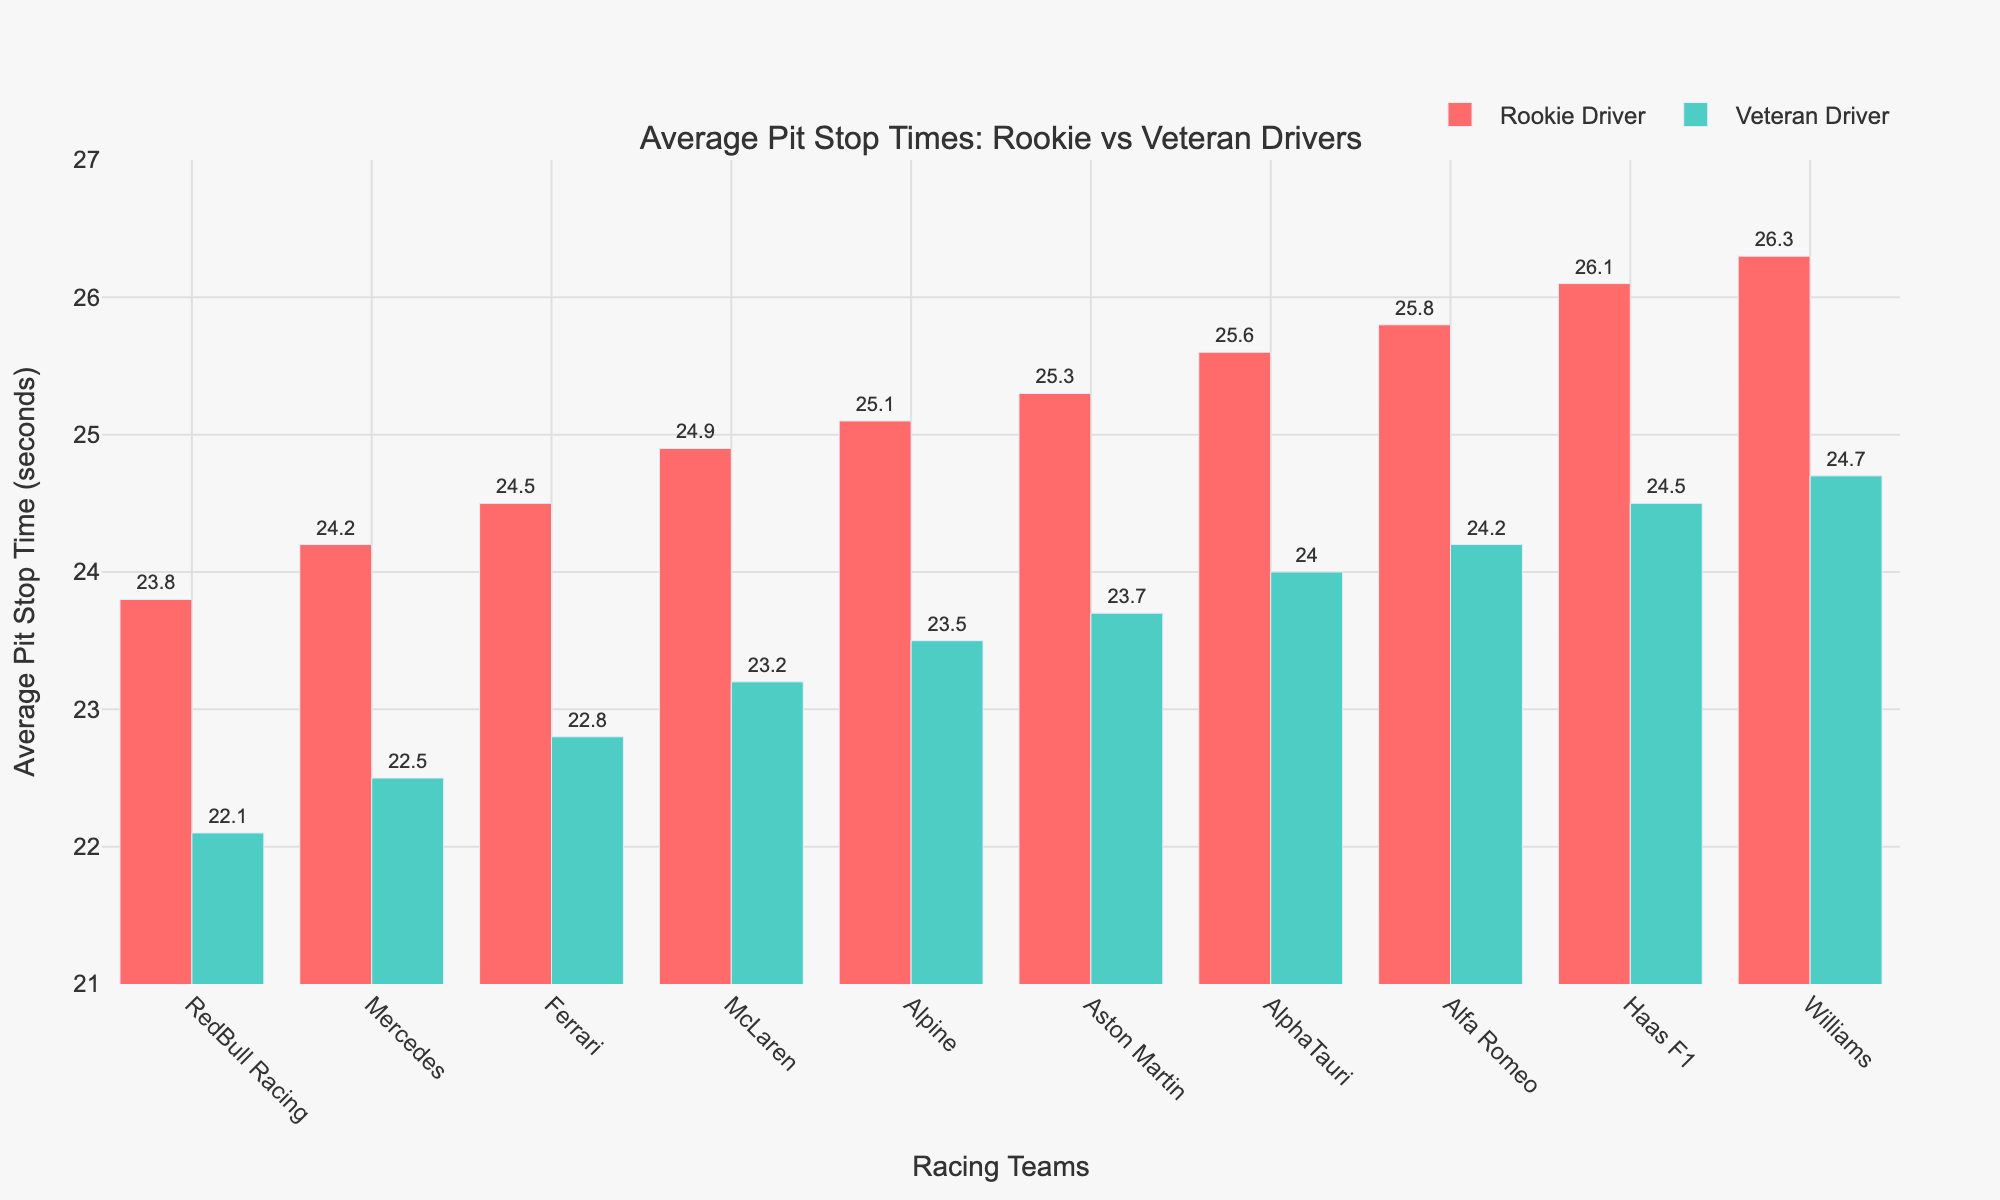Which team has the smallest difference in average pit stop times between rookie and veteran drivers? The smallest difference can be found by calculating the absolute difference between the pit stop times of rookie and veteran drivers for each team. RedBull Racing has the smallest difference:
Answer: RedBull Racing Which team's rookie driver has the longest average pit stop time? By visually identifying the tallest red bar on the chart, we see that Williams' rookie driver has the longest average pit stop time of 26.3 seconds.
Answer: Williams How does the average pit stop time of Mercedes' rookie driver compare to Alpine's veteran driver? Mercedes' rookie driver has an average pit stop time of 24.2 seconds, while Alpine's veteran driver has an average pit stop time of 23.5 seconds. Since 24.2 > 23.5, Mercedes' rookie driver has a longer average pit stop time.
Answer: Mercedes' rookie driver is slower What is the total of the average pit stop times for both rookie and veteran drivers of Ferrari? The average pit stop time of Ferrari's rookie driver is 24.5 seconds and the veteran driver's is 22.8 seconds. Their total is 24.5 + 22.8 = 47.3 seconds.
Answer: 47.3 seconds Is there any team where the veteran driver's average pit stop time is 2 seconds faster than the rookie driver's? None of the teams have a difference exactly equal to 2 seconds when comparing the veteran driver to the rookie driver based on the chart's data.
Answer: No Which driver between RedBull Racing and McLaren has the faster average pit stop time on the rookie side? Comparing the heights of the red bars for the two teams, RedBull Racing's rookie driver has a faster average pit stop time of 23.8 seconds compared to McLaren's 24.9 seconds.
Answer: RedBull Racing's rookie driver Do any teams have an average pit stop time for rookie drivers greater than 26 seconds? By looking at the height of the red bars, Williams’ and Haas F1’s rookie drivers have average pit stop times greater than 26 seconds (26.3 and 26.1 seconds, respectively).
Answer: Yes What is the difference in average pit stop times between rookie and veteran drivers for Aston Martin? Aston Martin's rookie driver averages 25.3 seconds and the veteran driver averages 23.7 seconds. The difference is 25.3 - 23.7 = 1.6 seconds.
Answer: 1.6 seconds Which team has the closest average pit stop times between rookie and veteran drivers without exceeding a difference of 2 seconds? By comparing the differences, RedBull Racing has the smallest difference of 1.7 seconds, which does not exceed 2 seconds.
Answer: RedBull Racing How much faster is RedBull Racing's veteran driver compared to Haas F1's veteran driver? RedBull Racing’s veteran driver averages 22.1 seconds, while Haas F1’s veteran driver averages 24.5 seconds. The difference is 24.5 - 22.1 = 2.4 seconds.
Answer: 2.4 seconds 